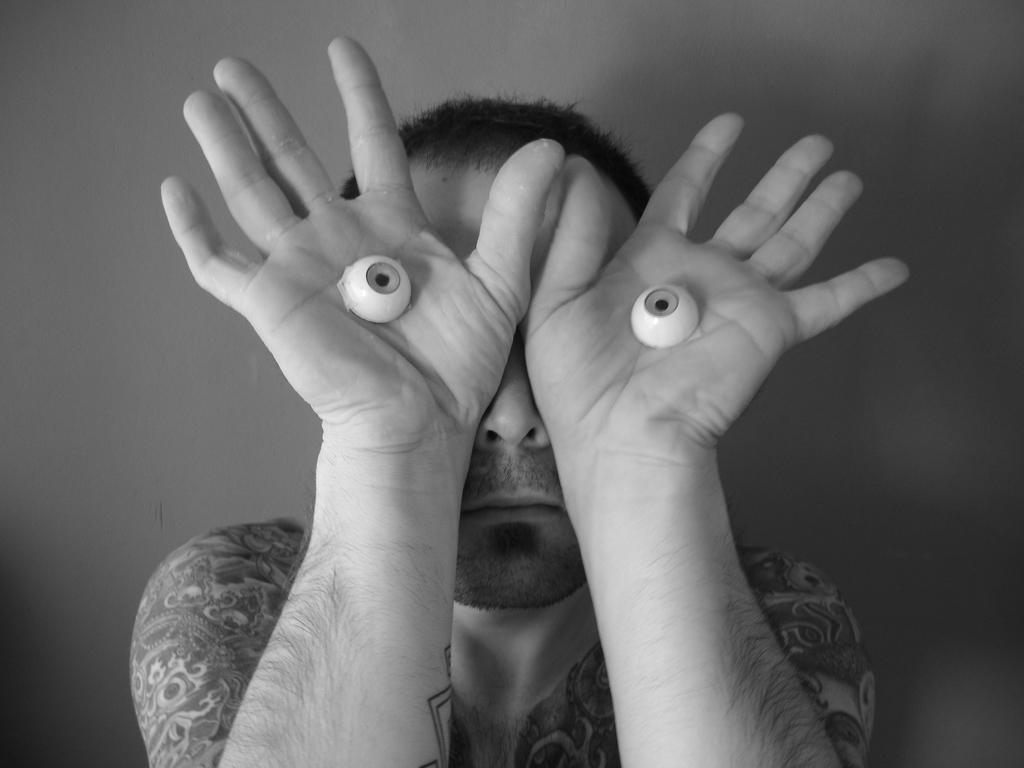What is the color scheme of the image? The image is black and white. Can you describe the person in the image? There is a man in the image. What is the man doing in the image? The man is holding an object in his hand. What type of crime is being committed in the image? There is no indication of a crime being committed in the image; it only shows a man holding an object in his hand. Can you describe the cushion on the chair in the image? There is no chair or cushion present in the image. 